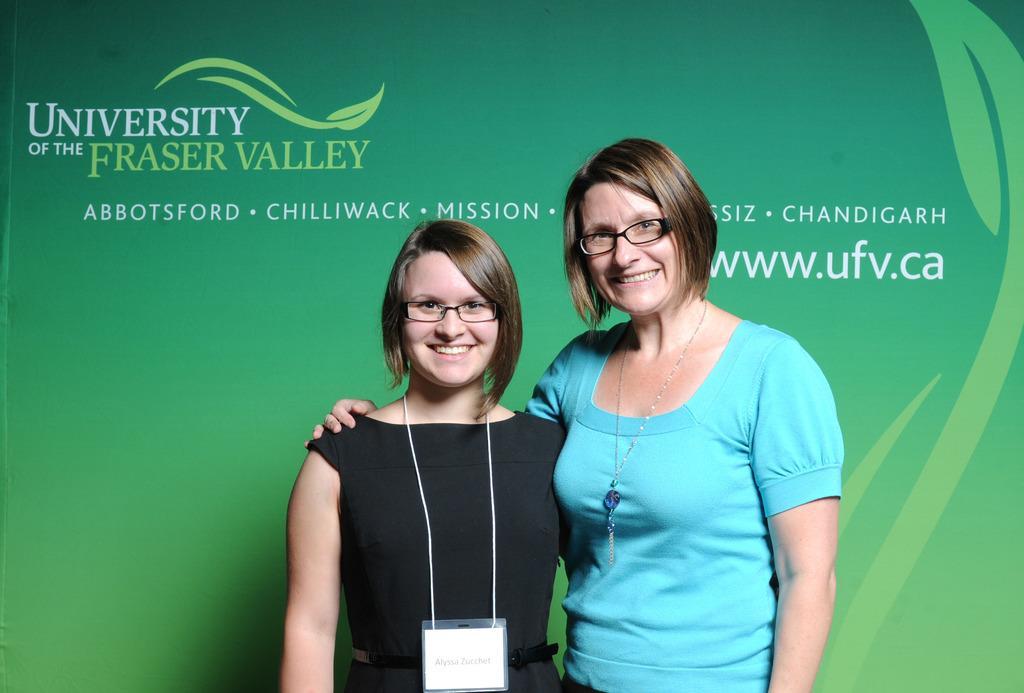Could you give a brief overview of what you see in this image? This image consists of two women. To the left, the woman is wearing black dress. To the right, the woman is wearing blue dress. In the background, there is a banner in green color. 